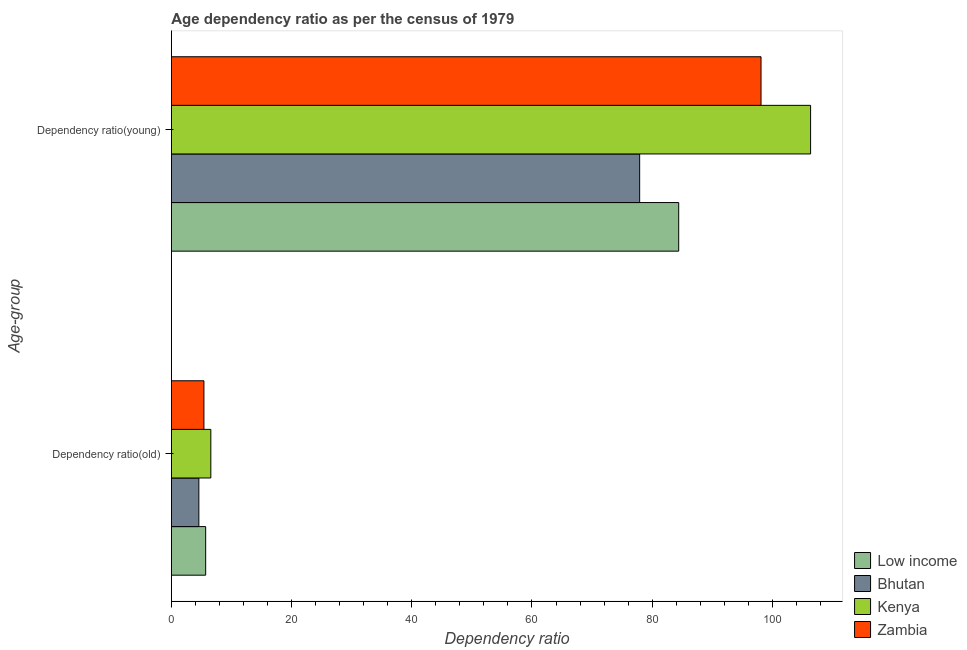How many different coloured bars are there?
Keep it short and to the point. 4. Are the number of bars per tick equal to the number of legend labels?
Keep it short and to the point. Yes. How many bars are there on the 2nd tick from the top?
Your response must be concise. 4. What is the label of the 2nd group of bars from the top?
Offer a very short reply. Dependency ratio(old). What is the age dependency ratio(old) in Zambia?
Give a very brief answer. 5.42. Across all countries, what is the maximum age dependency ratio(young)?
Your answer should be very brief. 106.36. Across all countries, what is the minimum age dependency ratio(young)?
Ensure brevity in your answer.  77.92. In which country was the age dependency ratio(old) maximum?
Ensure brevity in your answer.  Kenya. In which country was the age dependency ratio(old) minimum?
Your answer should be compact. Bhutan. What is the total age dependency ratio(old) in the graph?
Your answer should be compact. 22.26. What is the difference between the age dependency ratio(young) in Low income and that in Kenya?
Your answer should be very brief. -21.95. What is the difference between the age dependency ratio(young) in Bhutan and the age dependency ratio(old) in Zambia?
Your response must be concise. 72.5. What is the average age dependency ratio(old) per country?
Offer a very short reply. 5.56. What is the difference between the age dependency ratio(old) and age dependency ratio(young) in Zambia?
Your answer should be compact. -92.7. In how many countries, is the age dependency ratio(old) greater than 104 ?
Offer a terse response. 0. What is the ratio of the age dependency ratio(young) in Low income to that in Bhutan?
Offer a very short reply. 1.08. In how many countries, is the age dependency ratio(old) greater than the average age dependency ratio(old) taken over all countries?
Your response must be concise. 2. What does the 4th bar from the top in Dependency ratio(old) represents?
Keep it short and to the point. Low income. What does the 1st bar from the bottom in Dependency ratio(old) represents?
Make the answer very short. Low income. How many bars are there?
Make the answer very short. 8. Are all the bars in the graph horizontal?
Keep it short and to the point. Yes. Does the graph contain grids?
Offer a very short reply. No. Where does the legend appear in the graph?
Your answer should be compact. Bottom right. How many legend labels are there?
Your answer should be very brief. 4. How are the legend labels stacked?
Offer a terse response. Vertical. What is the title of the graph?
Offer a terse response. Age dependency ratio as per the census of 1979. What is the label or title of the X-axis?
Offer a terse response. Dependency ratio. What is the label or title of the Y-axis?
Provide a succinct answer. Age-group. What is the Dependency ratio in Low income in Dependency ratio(old)?
Offer a very short reply. 5.71. What is the Dependency ratio of Bhutan in Dependency ratio(old)?
Provide a succinct answer. 4.57. What is the Dependency ratio in Kenya in Dependency ratio(old)?
Give a very brief answer. 6.56. What is the Dependency ratio of Zambia in Dependency ratio(old)?
Offer a terse response. 5.42. What is the Dependency ratio of Low income in Dependency ratio(young)?
Keep it short and to the point. 84.41. What is the Dependency ratio in Bhutan in Dependency ratio(young)?
Give a very brief answer. 77.92. What is the Dependency ratio in Kenya in Dependency ratio(young)?
Give a very brief answer. 106.36. What is the Dependency ratio of Zambia in Dependency ratio(young)?
Your answer should be very brief. 98.11. Across all Age-group, what is the maximum Dependency ratio of Low income?
Provide a succinct answer. 84.41. Across all Age-group, what is the maximum Dependency ratio of Bhutan?
Offer a terse response. 77.92. Across all Age-group, what is the maximum Dependency ratio in Kenya?
Provide a succinct answer. 106.36. Across all Age-group, what is the maximum Dependency ratio in Zambia?
Provide a succinct answer. 98.11. Across all Age-group, what is the minimum Dependency ratio of Low income?
Offer a very short reply. 5.71. Across all Age-group, what is the minimum Dependency ratio of Bhutan?
Your answer should be compact. 4.57. Across all Age-group, what is the minimum Dependency ratio in Kenya?
Make the answer very short. 6.56. Across all Age-group, what is the minimum Dependency ratio in Zambia?
Offer a very short reply. 5.42. What is the total Dependency ratio in Low income in the graph?
Give a very brief answer. 90.12. What is the total Dependency ratio of Bhutan in the graph?
Your answer should be compact. 82.49. What is the total Dependency ratio of Kenya in the graph?
Ensure brevity in your answer.  112.92. What is the total Dependency ratio of Zambia in the graph?
Keep it short and to the point. 103.53. What is the difference between the Dependency ratio of Low income in Dependency ratio(old) and that in Dependency ratio(young)?
Your response must be concise. -78.71. What is the difference between the Dependency ratio of Bhutan in Dependency ratio(old) and that in Dependency ratio(young)?
Offer a very short reply. -73.35. What is the difference between the Dependency ratio of Kenya in Dependency ratio(old) and that in Dependency ratio(young)?
Offer a terse response. -99.8. What is the difference between the Dependency ratio of Zambia in Dependency ratio(old) and that in Dependency ratio(young)?
Your answer should be very brief. -92.7. What is the difference between the Dependency ratio in Low income in Dependency ratio(old) and the Dependency ratio in Bhutan in Dependency ratio(young)?
Give a very brief answer. -72.21. What is the difference between the Dependency ratio of Low income in Dependency ratio(old) and the Dependency ratio of Kenya in Dependency ratio(young)?
Keep it short and to the point. -100.65. What is the difference between the Dependency ratio in Low income in Dependency ratio(old) and the Dependency ratio in Zambia in Dependency ratio(young)?
Ensure brevity in your answer.  -92.41. What is the difference between the Dependency ratio in Bhutan in Dependency ratio(old) and the Dependency ratio in Kenya in Dependency ratio(young)?
Make the answer very short. -101.79. What is the difference between the Dependency ratio of Bhutan in Dependency ratio(old) and the Dependency ratio of Zambia in Dependency ratio(young)?
Your response must be concise. -93.54. What is the difference between the Dependency ratio of Kenya in Dependency ratio(old) and the Dependency ratio of Zambia in Dependency ratio(young)?
Ensure brevity in your answer.  -91.55. What is the average Dependency ratio of Low income per Age-group?
Your answer should be compact. 45.06. What is the average Dependency ratio of Bhutan per Age-group?
Give a very brief answer. 41.24. What is the average Dependency ratio of Kenya per Age-group?
Provide a succinct answer. 56.46. What is the average Dependency ratio of Zambia per Age-group?
Your answer should be very brief. 51.76. What is the difference between the Dependency ratio of Low income and Dependency ratio of Bhutan in Dependency ratio(old)?
Your answer should be compact. 1.13. What is the difference between the Dependency ratio in Low income and Dependency ratio in Kenya in Dependency ratio(old)?
Keep it short and to the point. -0.86. What is the difference between the Dependency ratio of Low income and Dependency ratio of Zambia in Dependency ratio(old)?
Your response must be concise. 0.29. What is the difference between the Dependency ratio of Bhutan and Dependency ratio of Kenya in Dependency ratio(old)?
Your answer should be very brief. -1.99. What is the difference between the Dependency ratio in Bhutan and Dependency ratio in Zambia in Dependency ratio(old)?
Offer a very short reply. -0.84. What is the difference between the Dependency ratio in Kenya and Dependency ratio in Zambia in Dependency ratio(old)?
Ensure brevity in your answer.  1.15. What is the difference between the Dependency ratio in Low income and Dependency ratio in Bhutan in Dependency ratio(young)?
Keep it short and to the point. 6.5. What is the difference between the Dependency ratio of Low income and Dependency ratio of Kenya in Dependency ratio(young)?
Your answer should be compact. -21.95. What is the difference between the Dependency ratio of Low income and Dependency ratio of Zambia in Dependency ratio(young)?
Provide a short and direct response. -13.7. What is the difference between the Dependency ratio in Bhutan and Dependency ratio in Kenya in Dependency ratio(young)?
Give a very brief answer. -28.44. What is the difference between the Dependency ratio of Bhutan and Dependency ratio of Zambia in Dependency ratio(young)?
Keep it short and to the point. -20.2. What is the difference between the Dependency ratio in Kenya and Dependency ratio in Zambia in Dependency ratio(young)?
Ensure brevity in your answer.  8.25. What is the ratio of the Dependency ratio in Low income in Dependency ratio(old) to that in Dependency ratio(young)?
Give a very brief answer. 0.07. What is the ratio of the Dependency ratio of Bhutan in Dependency ratio(old) to that in Dependency ratio(young)?
Your answer should be compact. 0.06. What is the ratio of the Dependency ratio of Kenya in Dependency ratio(old) to that in Dependency ratio(young)?
Ensure brevity in your answer.  0.06. What is the ratio of the Dependency ratio in Zambia in Dependency ratio(old) to that in Dependency ratio(young)?
Keep it short and to the point. 0.06. What is the difference between the highest and the second highest Dependency ratio in Low income?
Give a very brief answer. 78.71. What is the difference between the highest and the second highest Dependency ratio of Bhutan?
Provide a succinct answer. 73.35. What is the difference between the highest and the second highest Dependency ratio of Kenya?
Your answer should be very brief. 99.8. What is the difference between the highest and the second highest Dependency ratio in Zambia?
Your answer should be compact. 92.7. What is the difference between the highest and the lowest Dependency ratio in Low income?
Make the answer very short. 78.71. What is the difference between the highest and the lowest Dependency ratio of Bhutan?
Give a very brief answer. 73.35. What is the difference between the highest and the lowest Dependency ratio in Kenya?
Give a very brief answer. 99.8. What is the difference between the highest and the lowest Dependency ratio in Zambia?
Your answer should be compact. 92.7. 